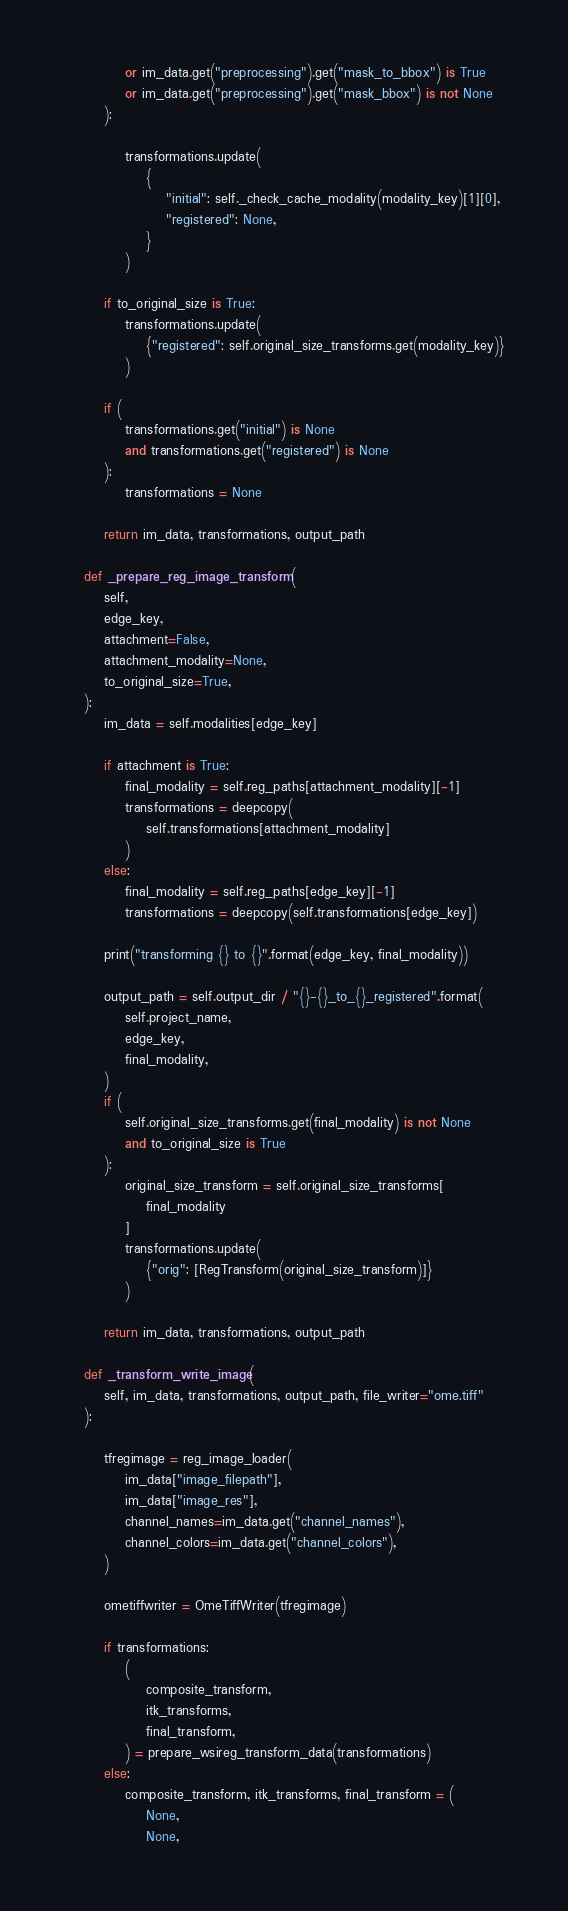<code> <loc_0><loc_0><loc_500><loc_500><_Python_>            or im_data.get("preprocessing").get("mask_to_bbox") is True
            or im_data.get("preprocessing").get("mask_bbox") is not None
        ):

            transformations.update(
                {
                    "initial": self._check_cache_modality(modality_key)[1][0],
                    "registered": None,
                }
            )

        if to_original_size is True:
            transformations.update(
                {"registered": self.original_size_transforms.get(modality_key)}
            )

        if (
            transformations.get("initial") is None
            and transformations.get("registered") is None
        ):
            transformations = None

        return im_data, transformations, output_path

    def _prepare_reg_image_transform(
        self,
        edge_key,
        attachment=False,
        attachment_modality=None,
        to_original_size=True,
    ):
        im_data = self.modalities[edge_key]

        if attachment is True:
            final_modality = self.reg_paths[attachment_modality][-1]
            transformations = deepcopy(
                self.transformations[attachment_modality]
            )
        else:
            final_modality = self.reg_paths[edge_key][-1]
            transformations = deepcopy(self.transformations[edge_key])

        print("transforming {} to {}".format(edge_key, final_modality))

        output_path = self.output_dir / "{}-{}_to_{}_registered".format(
            self.project_name,
            edge_key,
            final_modality,
        )
        if (
            self.original_size_transforms.get(final_modality) is not None
            and to_original_size is True
        ):
            original_size_transform = self.original_size_transforms[
                final_modality
            ]
            transformations.update(
                {"orig": [RegTransform(original_size_transform)]}
            )

        return im_data, transformations, output_path

    def _transform_write_image(
        self, im_data, transformations, output_path, file_writer="ome.tiff"
    ):

        tfregimage = reg_image_loader(
            im_data["image_filepath"],
            im_data["image_res"],
            channel_names=im_data.get("channel_names"),
            channel_colors=im_data.get("channel_colors"),
        )

        ometiffwriter = OmeTiffWriter(tfregimage)

        if transformations:
            (
                composite_transform,
                itk_transforms,
                final_transform,
            ) = prepare_wsireg_transform_data(transformations)
        else:
            composite_transform, itk_transforms, final_transform = (
                None,
                None,</code> 